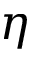<formula> <loc_0><loc_0><loc_500><loc_500>\eta</formula> 